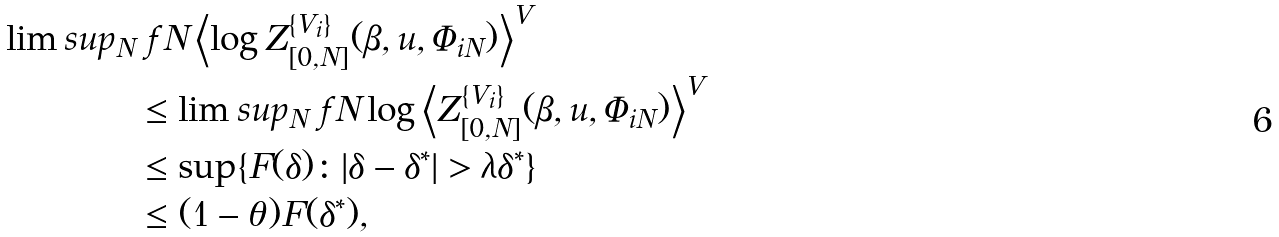Convert formula to latex. <formula><loc_0><loc_0><loc_500><loc_500>\lim s u p _ { N } & \ f N \left \langle \log Z _ { [ 0 , N ] } ^ { \{ V _ { i } \} } ( \beta , u , \Phi _ { i N } ) \right \rangle ^ { V } \\ & \leq \lim s u p _ { N } \ f N \log \left \langle Z _ { [ 0 , N ] } ^ { \{ V _ { i } \} } ( \beta , u , \Phi _ { i N } ) \right \rangle ^ { V } \\ & \leq \sup \{ F ( \delta ) \colon | \delta - \delta ^ { * } | > \lambda \delta ^ { * } \} \\ & \leq ( 1 - \theta ) F ( \delta ^ { * } ) ,</formula> 